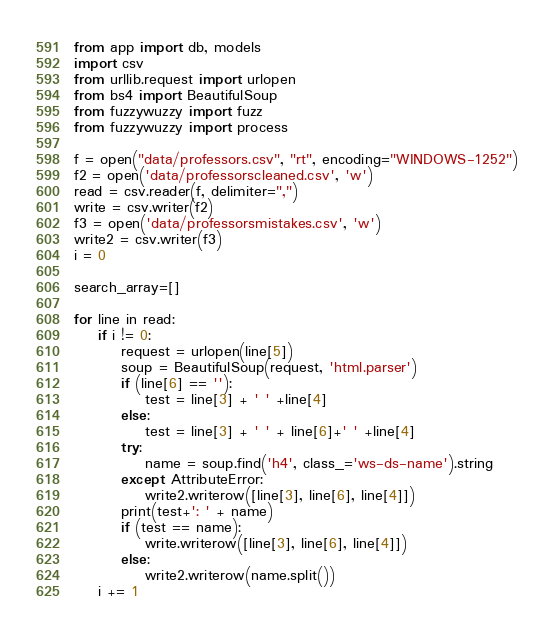Convert code to text. <code><loc_0><loc_0><loc_500><loc_500><_Python_>from app import db, models
import csv
from urllib.request import urlopen
from bs4 import BeautifulSoup
from fuzzywuzzy import fuzz
from fuzzywuzzy import process

f = open("data/professors.csv", "rt", encoding="WINDOWS-1252")
f2 = open('data/professorscleaned.csv', 'w')
read = csv.reader(f, delimiter=",")
write = csv.writer(f2)
f3 = open('data/professorsmistakes.csv', 'w')
write2 = csv.writer(f3)
i = 0

search_array=[]

for line in read:
    if i != 0:
        request = urlopen(line[5])
        soup = BeautifulSoup(request, 'html.parser')
        if (line[6] == ''):
            test = line[3] + ' ' +line[4]
        else:
            test = line[3] + ' ' + line[6]+' ' +line[4]
        try:
            name = soup.find('h4', class_='ws-ds-name').string
        except AttributeError:
            write2.writerow([line[3], line[6], line[4]])
        print(test+': ' + name)
        if (test == name):
            write.writerow([line[3], line[6], line[4]])
        else:
            write2.writerow(name.split())
    i += 1
</code> 